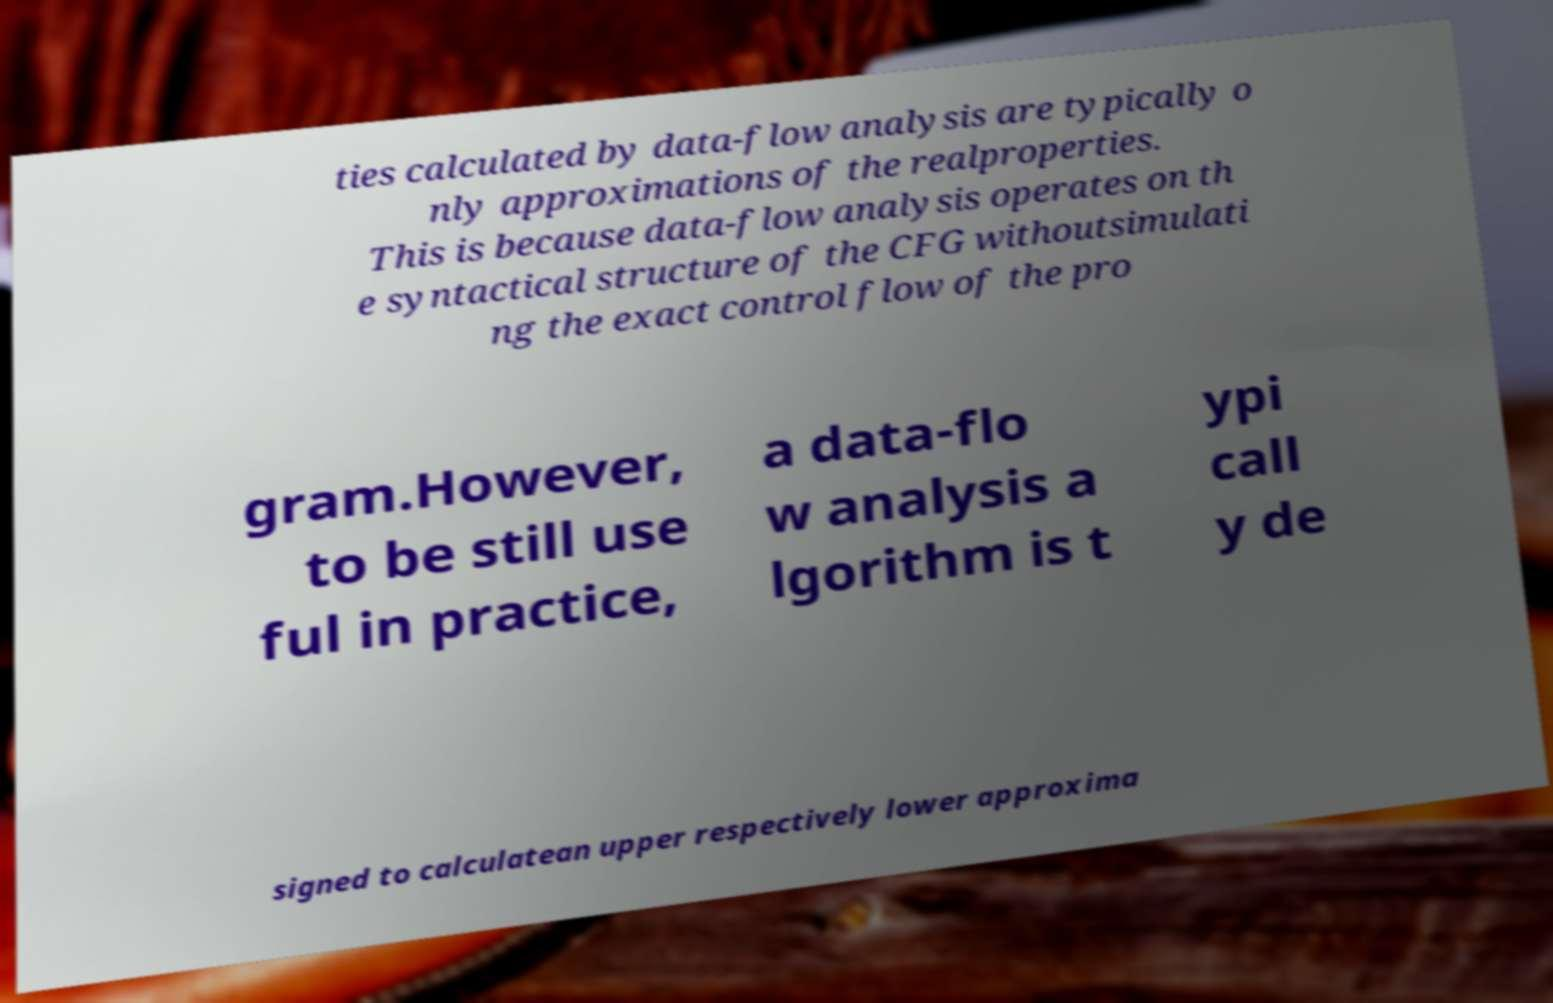Please identify and transcribe the text found in this image. ties calculated by data-flow analysis are typically o nly approximations of the realproperties. This is because data-flow analysis operates on th e syntactical structure of the CFG withoutsimulati ng the exact control flow of the pro gram.However, to be still use ful in practice, a data-flo w analysis a lgorithm is t ypi call y de signed to calculatean upper respectively lower approxima 